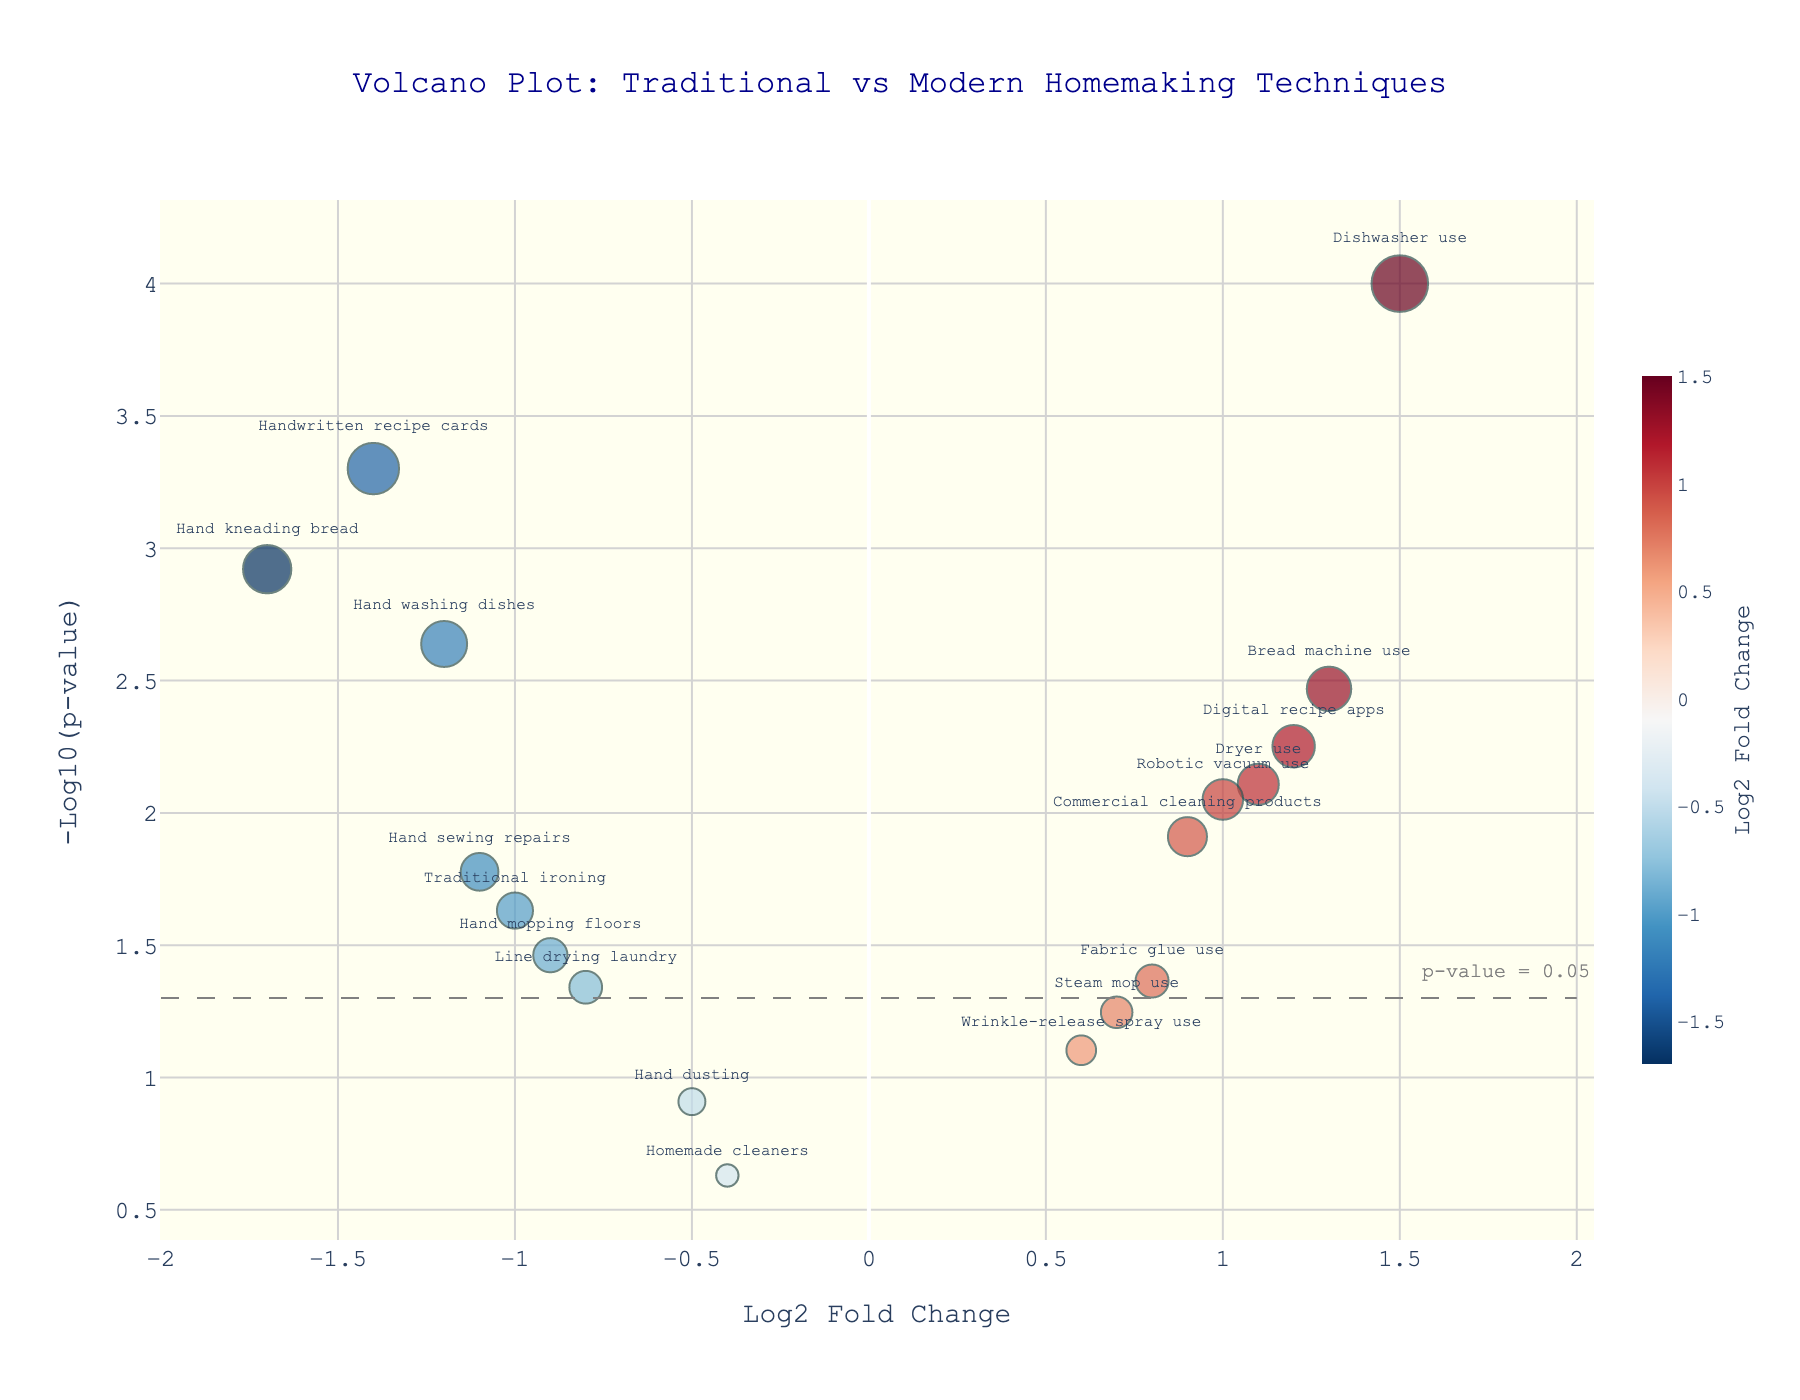How many techniques are shown in the plot? To find the number of techniques, count the number of data points in the plot. Each point represents a technique.
Answer: 18 What color scale is used to represent the Log2 Fold Change? The visual cue for the Log2 Fold Change is shown using colors. Observe the color bar on the plot's right side, which signifies a gradient from blue to red.
Answer: A gradient from blue to red Which technique has the highest -log10(p-value)? Look at the y-axis to see which point reaches the highest vertical position since the y-axis represents -log10(p-value). The point closest to the top indicates the highest value.
Answer: Dishwasher use Which traditional technique is the most time-consuming based on Log2 Fold Change? Traditional techniques have negative Log2 Fold Change values. The most negative value indicates the technique that is significantly less efficient. Look at the x-axis for the most negative value.
Answer: Hand kneading bread What is the cutoff for statistical significance in this plot? The plot has a line annotation at a certain y-value labeled as 'p-value = 0.05'. This line indicates the threshold for statistical significance. To convert p-value to -log10(p-value), use the threshold given.
Answer: 1.3 Which modern technique is the least effective based on the Log2 Fold Change? Modern techniques have positive Log2 Fold Change values. The lowest positive value will indicate the least effective modern technique. Check between 0 and the lowest positive value on the x-axis.
Answer: Steam mop use How many techniques have a p-value less than 0.05? Techniques with a significant p-value will be above the threshold line at y=1.3 on the plot. Count all the points above this line.
Answer: 12 Which technique shows the most significant p-value improvement when compared to its traditional counterpart? Compare pairs of traditional and modern techniques. Dyson points show both high -log10(p-value) and positive Log2 Fold Change values. Identify the pair with the largest improvement.
Answer: Dishwasher use What does a positive Log2 Fold Change indicate in the context of this plot? A positive Log2 Fold Change indicates that the modern homemaking technique is more time-efficient or effective compared to the traditional method. Judge direction on the x-axis for positive values.
Answer: Modern technique is more efficient or effective Which pair of techniques (one traditional and one modern) has the smallest difference in Log2 Fold Change? Calculate the absolute differences between each traditional and its modern counterpart Log2 Fold Change values. Find the pair with the minimum difference.
Answer: Hand dusting and Robotic vacuum use 